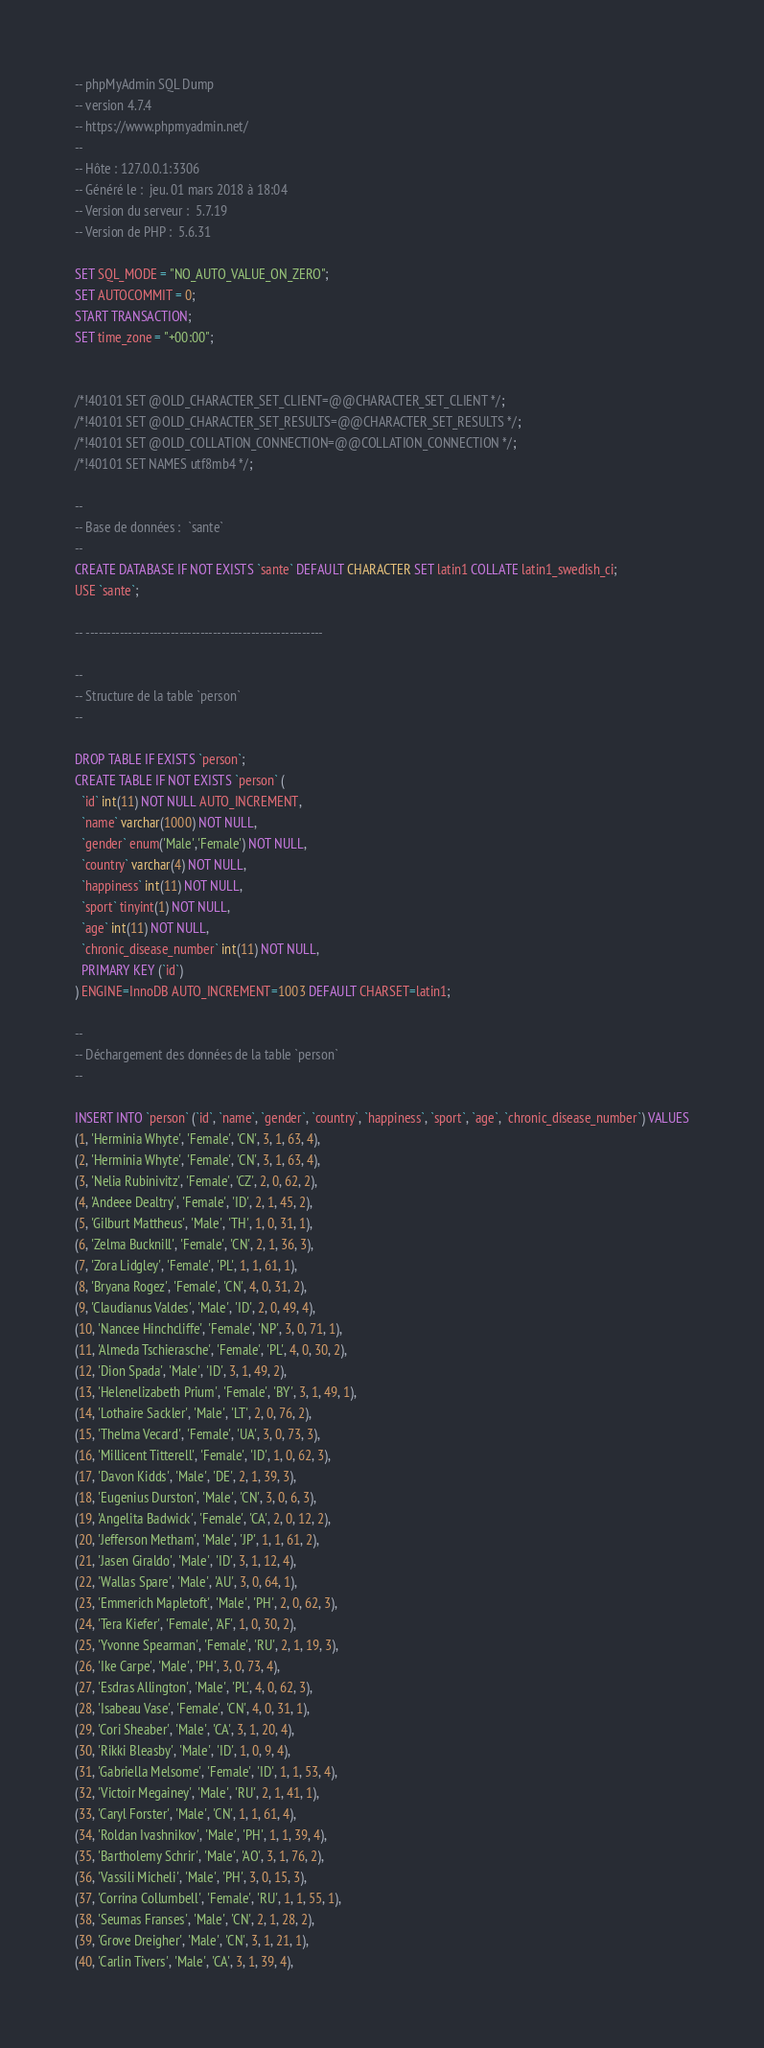Convert code to text. <code><loc_0><loc_0><loc_500><loc_500><_SQL_>-- phpMyAdmin SQL Dump
-- version 4.7.4
-- https://www.phpmyadmin.net/
--
-- Hôte : 127.0.0.1:3306
-- Généré le :  jeu. 01 mars 2018 à 18:04
-- Version du serveur :  5.7.19
-- Version de PHP :  5.6.31

SET SQL_MODE = "NO_AUTO_VALUE_ON_ZERO";
SET AUTOCOMMIT = 0;
START TRANSACTION;
SET time_zone = "+00:00";


/*!40101 SET @OLD_CHARACTER_SET_CLIENT=@@CHARACTER_SET_CLIENT */;
/*!40101 SET @OLD_CHARACTER_SET_RESULTS=@@CHARACTER_SET_RESULTS */;
/*!40101 SET @OLD_COLLATION_CONNECTION=@@COLLATION_CONNECTION */;
/*!40101 SET NAMES utf8mb4 */;

--
-- Base de données :  `sante`
--
CREATE DATABASE IF NOT EXISTS `sante` DEFAULT CHARACTER SET latin1 COLLATE latin1_swedish_ci;
USE `sante`;

-- --------------------------------------------------------

--
-- Structure de la table `person`
--

DROP TABLE IF EXISTS `person`;
CREATE TABLE IF NOT EXISTS `person` (
  `id` int(11) NOT NULL AUTO_INCREMENT,
  `name` varchar(1000) NOT NULL,
  `gender` enum('Male','Female') NOT NULL,
  `country` varchar(4) NOT NULL,
  `happiness` int(11) NOT NULL,
  `sport` tinyint(1) NOT NULL,
  `age` int(11) NOT NULL,
  `chronic_disease_number` int(11) NOT NULL,
  PRIMARY KEY (`id`)
) ENGINE=InnoDB AUTO_INCREMENT=1003 DEFAULT CHARSET=latin1;

--
-- Déchargement des données de la table `person`
--

INSERT INTO `person` (`id`, `name`, `gender`, `country`, `happiness`, `sport`, `age`, `chronic_disease_number`) VALUES
(1, 'Herminia Whyte', 'Female', 'CN', 3, 1, 63, 4),
(2, 'Herminia Whyte', 'Female', 'CN', 3, 1, 63, 4),
(3, 'Nelia Rubinivitz', 'Female', 'CZ', 2, 0, 62, 2),
(4, 'Andeee Dealtry', 'Female', 'ID', 2, 1, 45, 2),
(5, 'Gilburt Mattheus', 'Male', 'TH', 1, 0, 31, 1),
(6, 'Zelma Bucknill', 'Female', 'CN', 2, 1, 36, 3),
(7, 'Zora Lidgley', 'Female', 'PL', 1, 1, 61, 1),
(8, 'Bryana Rogez', 'Female', 'CN', 4, 0, 31, 2),
(9, 'Claudianus Valdes', 'Male', 'ID', 2, 0, 49, 4),
(10, 'Nancee Hinchcliffe', 'Female', 'NP', 3, 0, 71, 1),
(11, 'Almeda Tschierasche', 'Female', 'PL', 4, 0, 30, 2),
(12, 'Dion Spada', 'Male', 'ID', 3, 1, 49, 2),
(13, 'Helenelizabeth Prium', 'Female', 'BY', 3, 1, 49, 1),
(14, 'Lothaire Sackler', 'Male', 'LT', 2, 0, 76, 2),
(15, 'Thelma Vecard', 'Female', 'UA', 3, 0, 73, 3),
(16, 'Millicent Titterell', 'Female', 'ID', 1, 0, 62, 3),
(17, 'Davon Kidds', 'Male', 'DE', 2, 1, 39, 3),
(18, 'Eugenius Durston', 'Male', 'CN', 3, 0, 6, 3),
(19, 'Angelita Badwick', 'Female', 'CA', 2, 0, 12, 2),
(20, 'Jefferson Metham', 'Male', 'JP', 1, 1, 61, 2),
(21, 'Jasen Giraldo', 'Male', 'ID', 3, 1, 12, 4),
(22, 'Wallas Spare', 'Male', 'AU', 3, 0, 64, 1),
(23, 'Emmerich Mapletoft', 'Male', 'PH', 2, 0, 62, 3),
(24, 'Tera Kiefer', 'Female', 'AF', 1, 0, 30, 2),
(25, 'Yvonne Spearman', 'Female', 'RU', 2, 1, 19, 3),
(26, 'Ike Carpe', 'Male', 'PH', 3, 0, 73, 4),
(27, 'Esdras Allington', 'Male', 'PL', 4, 0, 62, 3),
(28, 'Isabeau Vase', 'Female', 'CN', 4, 0, 31, 1),
(29, 'Cori Sheaber', 'Male', 'CA', 3, 1, 20, 4),
(30, 'Rikki Bleasby', 'Male', 'ID', 1, 0, 9, 4),
(31, 'Gabriella Melsome', 'Female', 'ID', 1, 1, 53, 4),
(32, 'Victoir Megainey', 'Male', 'RU', 2, 1, 41, 1),
(33, 'Caryl Forster', 'Male', 'CN', 1, 1, 61, 4),
(34, 'Roldan Ivashnikov', 'Male', 'PH', 1, 1, 39, 4),
(35, 'Bartholemy Schrir', 'Male', 'AO', 3, 1, 76, 2),
(36, 'Vassili Micheli', 'Male', 'PH', 3, 0, 15, 3),
(37, 'Corrina Collumbell', 'Female', 'RU', 1, 1, 55, 1),
(38, 'Seumas Franses', 'Male', 'CN', 2, 1, 28, 2),
(39, 'Grove Dreigher', 'Male', 'CN', 3, 1, 21, 1),
(40, 'Carlin Tivers', 'Male', 'CA', 3, 1, 39, 4),</code> 